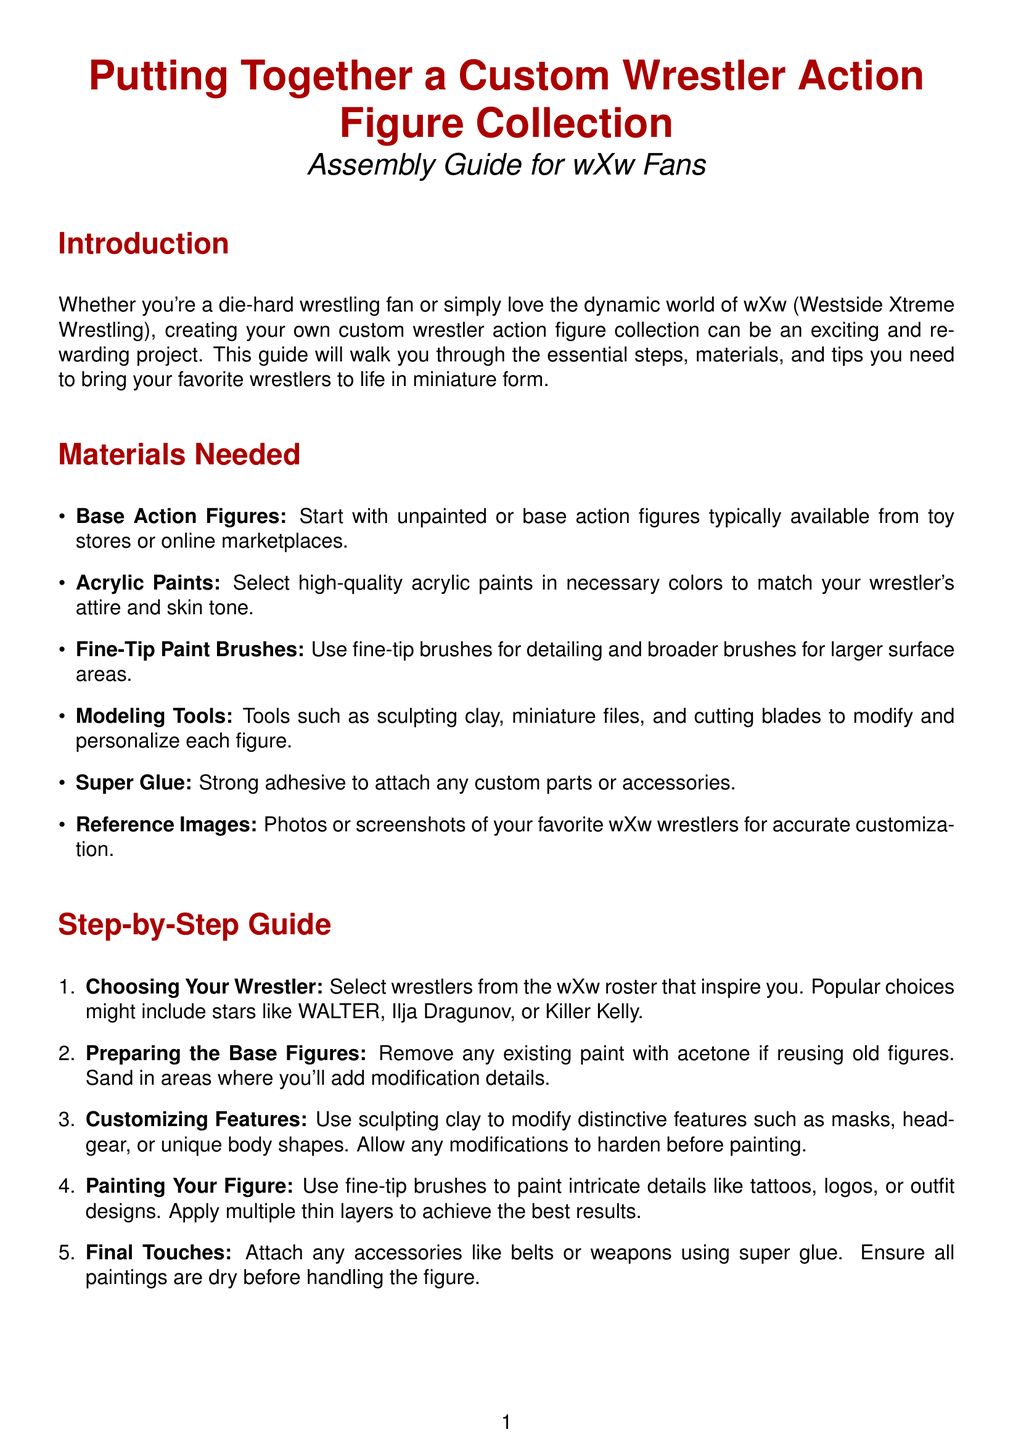What is the primary theme of this document? The document primarily focuses on creating custom wrestler action figures for wXw fans.
Answer: Custom wrestler action figures How many steps are outlined in the step-by-step guide? The guide lists a total of five distinct steps to follow for assembly.
Answer: Five Which material is suggested for detailing? Fine-tip paint brushes are recommended for intricate detailing of the figures.
Answer: Fine-tip paint brushes What should you do with existing paint if reusing old figures? The document advises removing any existing paint with acetone when reusing figures.
Answer: Remove with acetone Name one popular wrestler mentioned for customization. The guide provides examples like WALTER, Ilja Dragunov, or Killer Kelly.
Answer: WALTER What is one of the pro tips for customizing figures? One pro tip suggests sketching designs and listing modifications before starting the assembly process.
Answer: Plan Ahead Which type of paint is recommended for the project? High-quality acrylic paints are recommended to match the wrestlers' attire and skin tone.
Answer: Acrylic paints What should be done after painting the figure? After painting, the document states to attach any accessories using super glue.
Answer: Attach accessories 